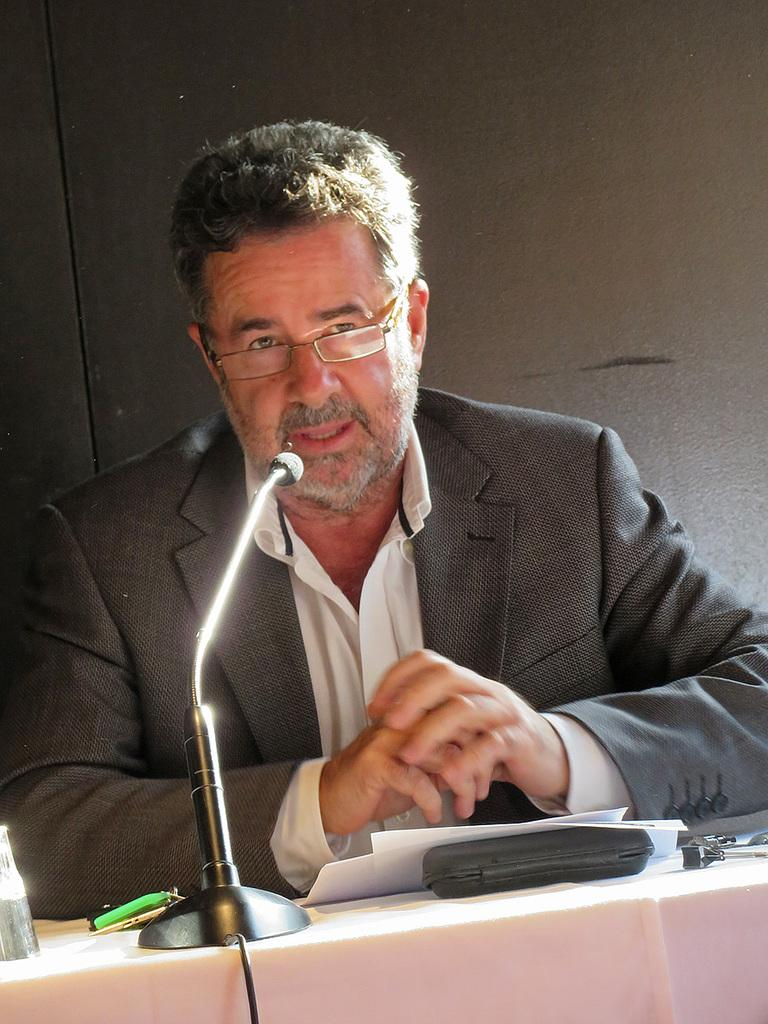Who or what is in the image? There is a person in the image. What can be seen in the background of the image? There is a microphone, papers, a box, and other objects visible in the background. Can you describe the microphone in the background? The microphone is visible in the background, but no further details are provided. How does the person in the image react to the sudden earthquake? There is no mention of an earthquake in the image or the provided facts, so it cannot be determined how the person would react. 